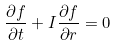Convert formula to latex. <formula><loc_0><loc_0><loc_500><loc_500>\frac { \partial f } { \partial t } + I \frac { \partial f } { \partial r } = 0</formula> 